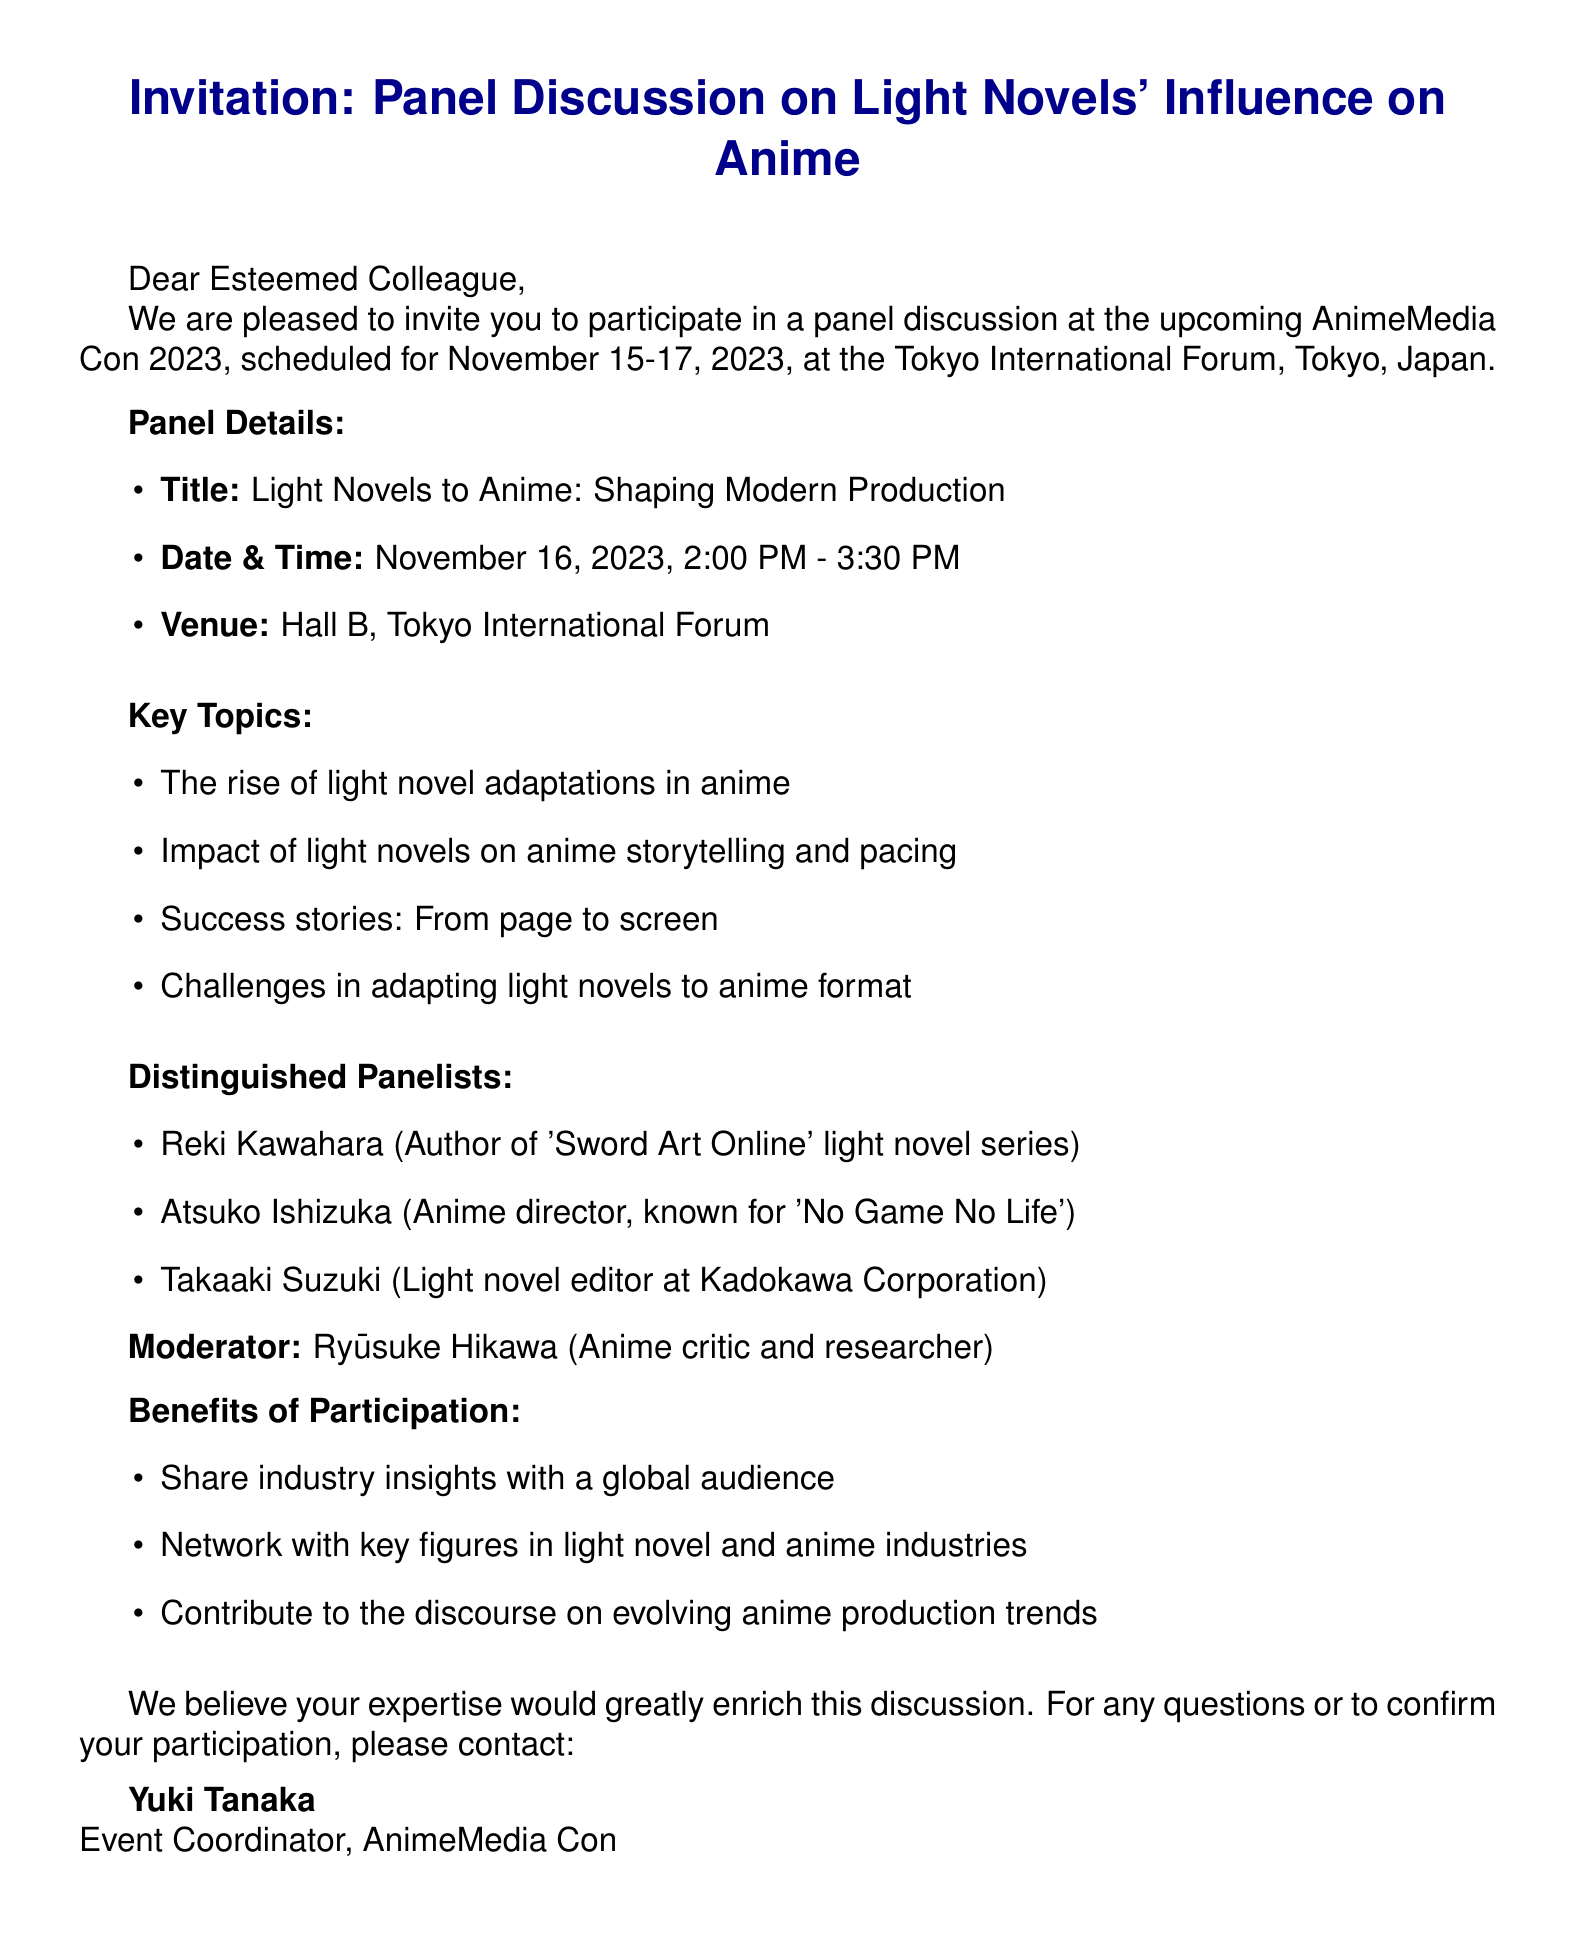What is the name of the event? The name of the event is mentioned in the document as AnimeMedia Con 2023.
Answer: AnimeMedia Con 2023 When will the panel discussion take place? The document states that the panel discussion will occur on November 16, 2023.
Answer: November 16, 2023 Who is the moderator of the panel? The document specifies that the moderator is Ryūsuke Hikawa.
Answer: Ryūsuke Hikawa What are the key topics addressed in the panel? The document lists the key topics in the panel, including the rise of light novel adaptations in anime.
Answer: The rise of light novel adaptations in anime What is one benefit of participation mentioned in the document? The document outlines benefits, one being the opportunity to share industry insights with a global audience.
Answer: Share industry insights with a global audience How long is the panel discussion scheduled for? The document indicates the panel discussion is scheduled for 1 hour and 30 minutes.
Answer: 1 hour and 30 minutes What venue will the panel take place in? According to the document, the venue for the panel discussion is Hall B.
Answer: Hall B Who can be contacted for more information about the event? The document identifies Yuki Tanaka as the contact person for further inquiries.
Answer: Yuki Tanaka What type of event is AnimeMedia Con 2023? The document describes AnimeMedia Con 2023 as a media conference.
Answer: media conference 